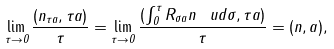Convert formula to latex. <formula><loc_0><loc_0><loc_500><loc_500>\lim _ { \tau \to 0 } \frac { ( n _ { \tau a } , \tau a ) } { \tau } = \lim _ { \tau \to 0 } \frac { ( \int _ { 0 } ^ { \tau } R _ { \sigma a } n \, \ u d \sigma , \tau a ) } { \tau } = ( n , a ) ,</formula> 